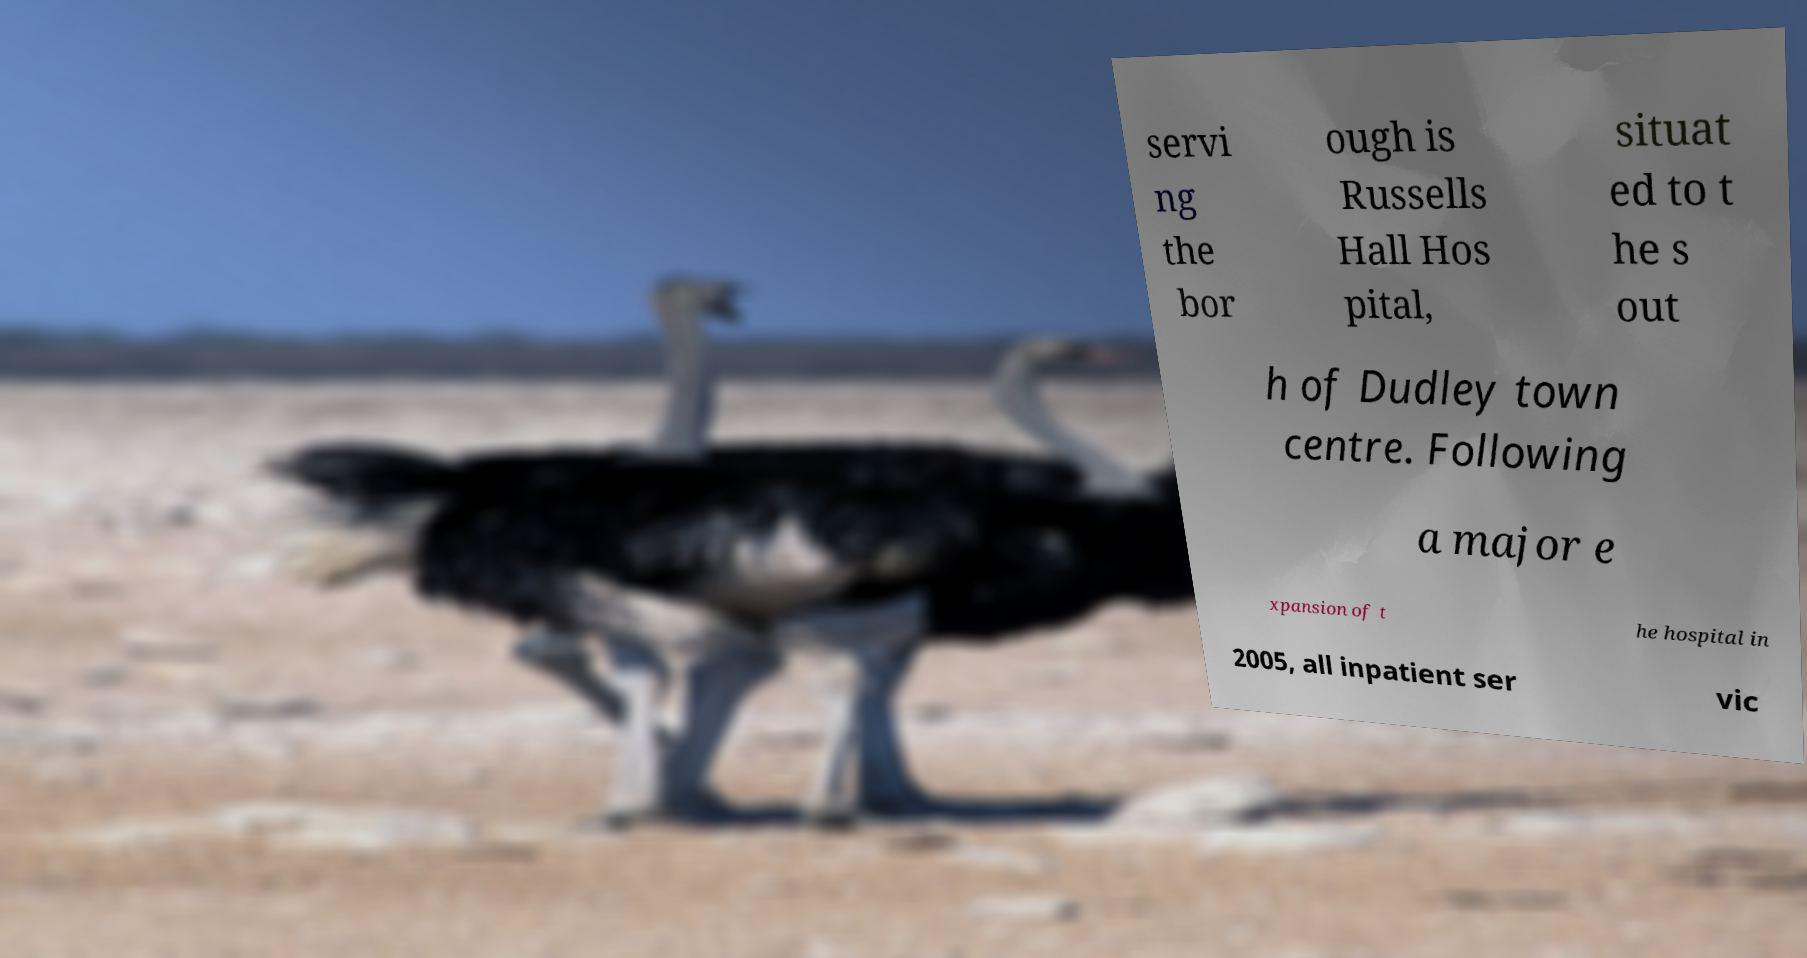For documentation purposes, I need the text within this image transcribed. Could you provide that? servi ng the bor ough is Russells Hall Hos pital, situat ed to t he s out h of Dudley town centre. Following a major e xpansion of t he hospital in 2005, all inpatient ser vic 